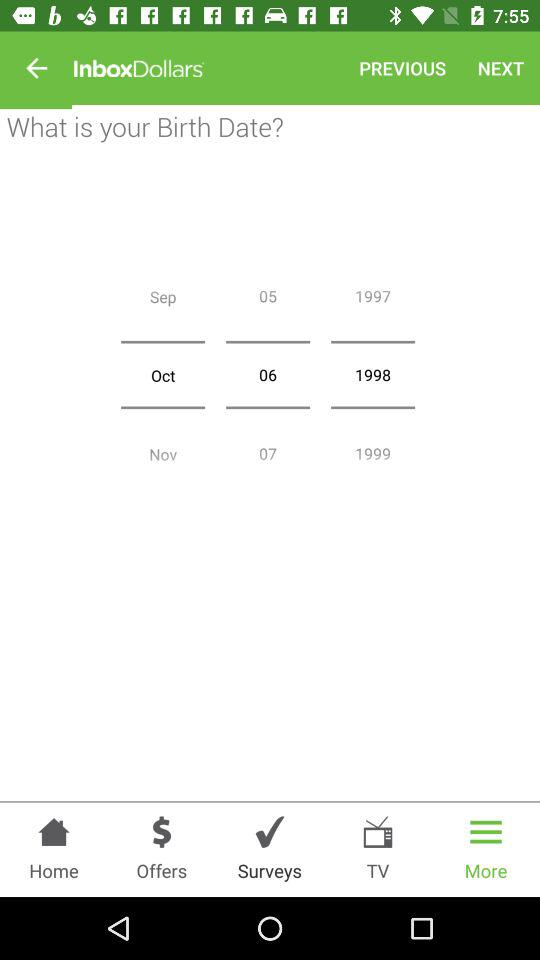What is the month of birth? The month of birth is October. 